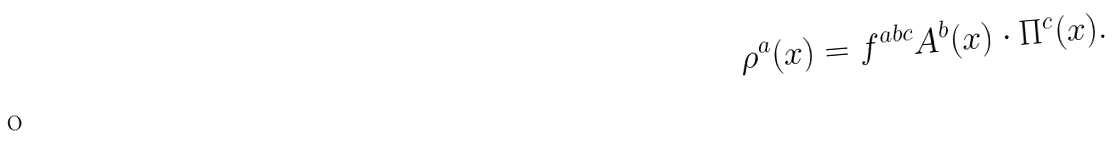<formula> <loc_0><loc_0><loc_500><loc_500>\rho ^ { a } ( { x } ) = f ^ { a b c } { A } ^ { b } ( { x } ) \cdot { \Pi } ^ { c } ( { x } ) .</formula> 